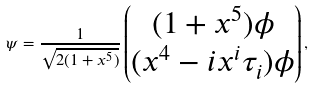Convert formula to latex. <formula><loc_0><loc_0><loc_500><loc_500>\psi = \frac { 1 } { \sqrt { 2 ( 1 + x ^ { 5 } ) } } \begin{pmatrix} ( 1 + x ^ { 5 } ) \phi \\ ( x ^ { 4 } - i x ^ { i } \tau _ { i } ) \phi \end{pmatrix} ,</formula> 